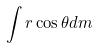Convert formula to latex. <formula><loc_0><loc_0><loc_500><loc_500>\int r \cos \theta d m</formula> 